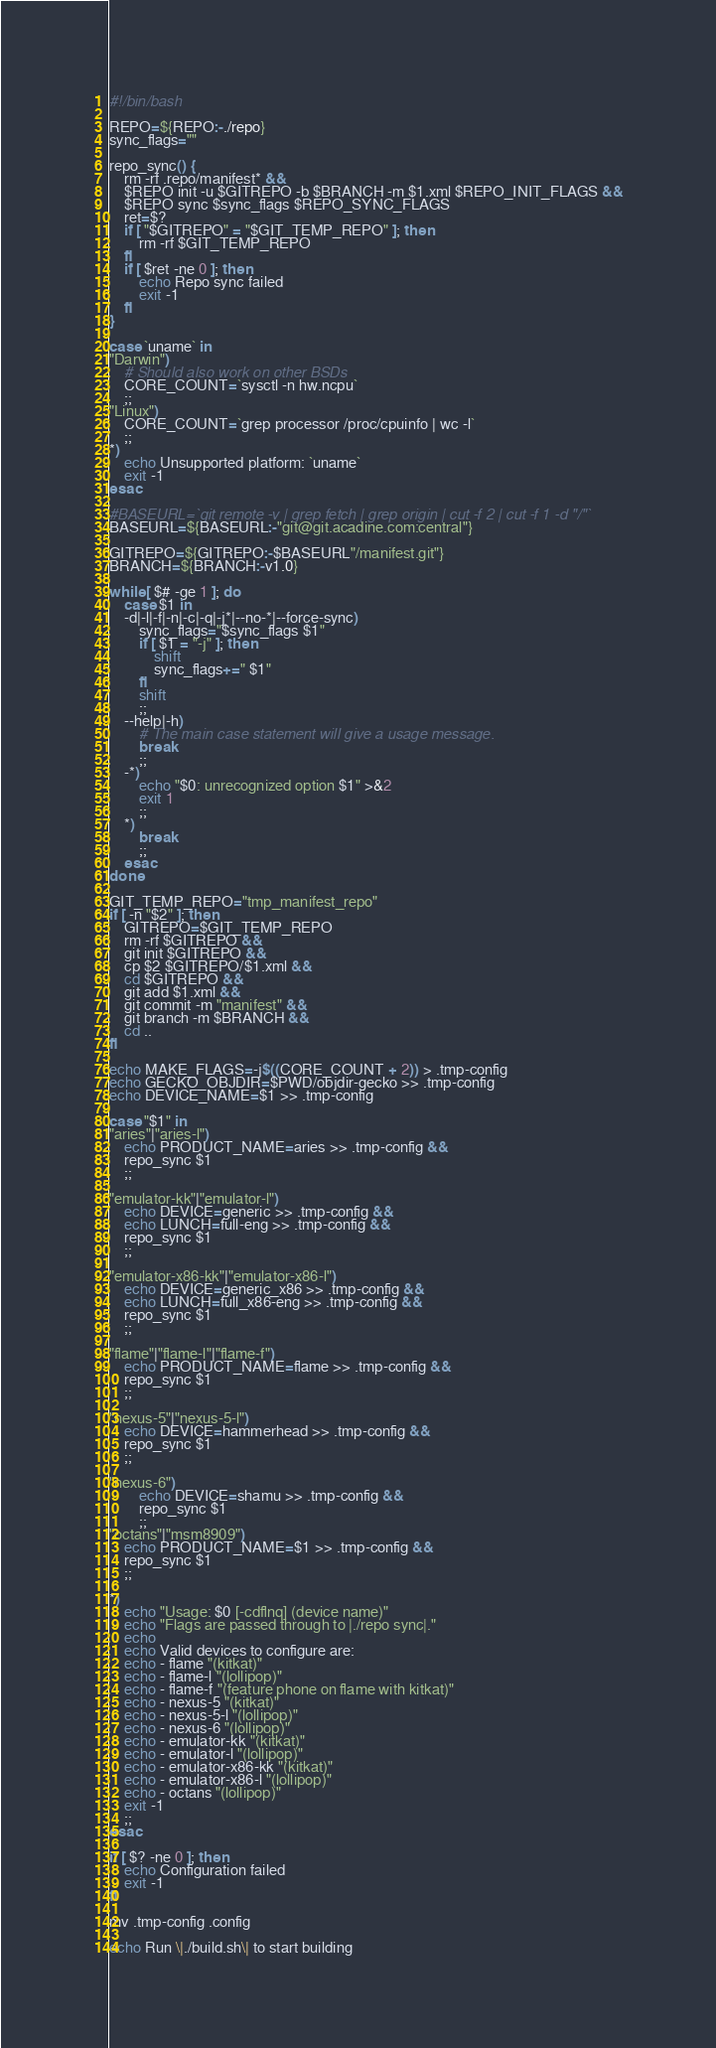<code> <loc_0><loc_0><loc_500><loc_500><_Bash_>#!/bin/bash

REPO=${REPO:-./repo}
sync_flags=""

repo_sync() {
	rm -rf .repo/manifest* &&
	$REPO init -u $GITREPO -b $BRANCH -m $1.xml $REPO_INIT_FLAGS &&
	$REPO sync $sync_flags $REPO_SYNC_FLAGS
	ret=$?
	if [ "$GITREPO" = "$GIT_TEMP_REPO" ]; then
		rm -rf $GIT_TEMP_REPO
	fi
	if [ $ret -ne 0 ]; then
		echo Repo sync failed
		exit -1
	fi
}

case `uname` in
"Darwin")
	# Should also work on other BSDs
	CORE_COUNT=`sysctl -n hw.ncpu`
	;;
"Linux")
	CORE_COUNT=`grep processor /proc/cpuinfo | wc -l`
	;;
*)
	echo Unsupported platform: `uname`
	exit -1
esac

#BASEURL=`git remote -v | grep fetch | grep origin | cut -f 2 | cut -f 1 -d "/"`
BASEURL=${BASEURL:-"git@git.acadine.com:central"}

GITREPO=${GITREPO:-$BASEURL"/manifest.git"}
BRANCH=${BRANCH:-v1.0}

while [ $# -ge 1 ]; do
	case $1 in
	-d|-l|-f|-n|-c|-q|-j*|--no-*|--force-sync)
		sync_flags="$sync_flags $1"
		if [ $1 = "-j" ]; then
			shift
			sync_flags+=" $1"
		fi
		shift
		;;
	--help|-h)
		# The main case statement will give a usage message.
		break
		;;
	-*)
		echo "$0: unrecognized option $1" >&2
		exit 1
		;;
	*)
		break
		;;
	esac
done

GIT_TEMP_REPO="tmp_manifest_repo"
if [ -n "$2" ]; then
	GITREPO=$GIT_TEMP_REPO
	rm -rf $GITREPO &&
	git init $GITREPO &&
	cp $2 $GITREPO/$1.xml &&
	cd $GITREPO &&
	git add $1.xml &&
	git commit -m "manifest" &&
	git branch -m $BRANCH &&
	cd ..
fi

echo MAKE_FLAGS=-j$((CORE_COUNT + 2)) > .tmp-config
echo GECKO_OBJDIR=$PWD/objdir-gecko >> .tmp-config
echo DEVICE_NAME=$1 >> .tmp-config

case "$1" in
"aries"|"aries-l")
	echo PRODUCT_NAME=aries >> .tmp-config &&
	repo_sync $1
	;;

"emulator-kk"|"emulator-l")
	echo DEVICE=generic >> .tmp-config &&
	echo LUNCH=full-eng >> .tmp-config &&
	repo_sync $1
	;;

"emulator-x86-kk"|"emulator-x86-l")
	echo DEVICE=generic_x86 >> .tmp-config &&
	echo LUNCH=full_x86-eng >> .tmp-config &&
	repo_sync $1
	;;

"flame"|"flame-l"|"flame-f")
	echo PRODUCT_NAME=flame >> .tmp-config &&
	repo_sync $1
	;;

"nexus-5"|"nexus-5-l")
	echo DEVICE=hammerhead >> .tmp-config &&
	repo_sync $1
	;;

"nexus-6")
        echo DEVICE=shamu >> .tmp-config &&
        repo_sync $1
        ;;
"octans"|"msm8909")
	echo PRODUCT_NAME=$1 >> .tmp-config &&
	repo_sync $1
	;;

*)
	echo "Usage: $0 [-cdflnq] (device name)"
	echo "Flags are passed through to |./repo sync|."
	echo
	echo Valid devices to configure are:
	echo - flame "(kitkat)"
	echo - flame-l "(lollipop)"
	echo - flame-f "(feature phone on flame with kitkat)"
	echo - nexus-5 "(kitkat)"
	echo - nexus-5-l "(lollipop)"
	echo - nexus-6 "(lollipop)"
	echo - emulator-kk "(kitkat)"
	echo - emulator-l "(lollipop)"
	echo - emulator-x86-kk "(kitkat)"
	echo - emulator-x86-l "(lollipop)"
	echo - octans "(lollipop)"
	exit -1
	;;
esac

if [ $? -ne 0 ]; then
	echo Configuration failed
	exit -1
fi

mv .tmp-config .config

echo Run \|./build.sh\| to start building
</code> 